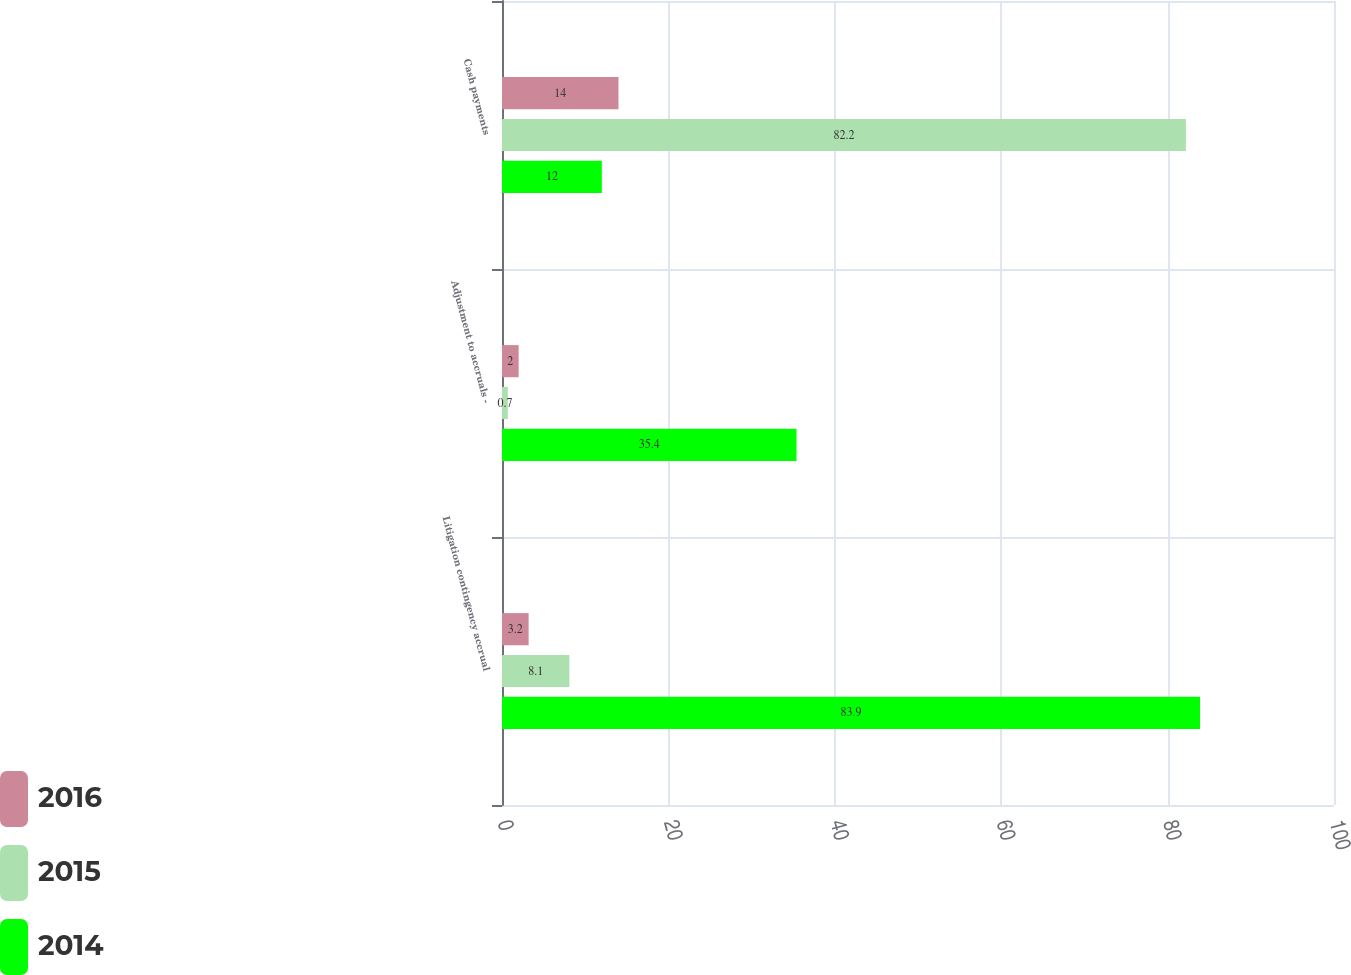Convert chart to OTSL. <chart><loc_0><loc_0><loc_500><loc_500><stacked_bar_chart><ecel><fcel>Litigation contingency accrual<fcel>Adjustment to accruals -<fcel>Cash payments<nl><fcel>2016<fcel>3.2<fcel>2<fcel>14<nl><fcel>2015<fcel>8.1<fcel>0.7<fcel>82.2<nl><fcel>2014<fcel>83.9<fcel>35.4<fcel>12<nl></chart> 